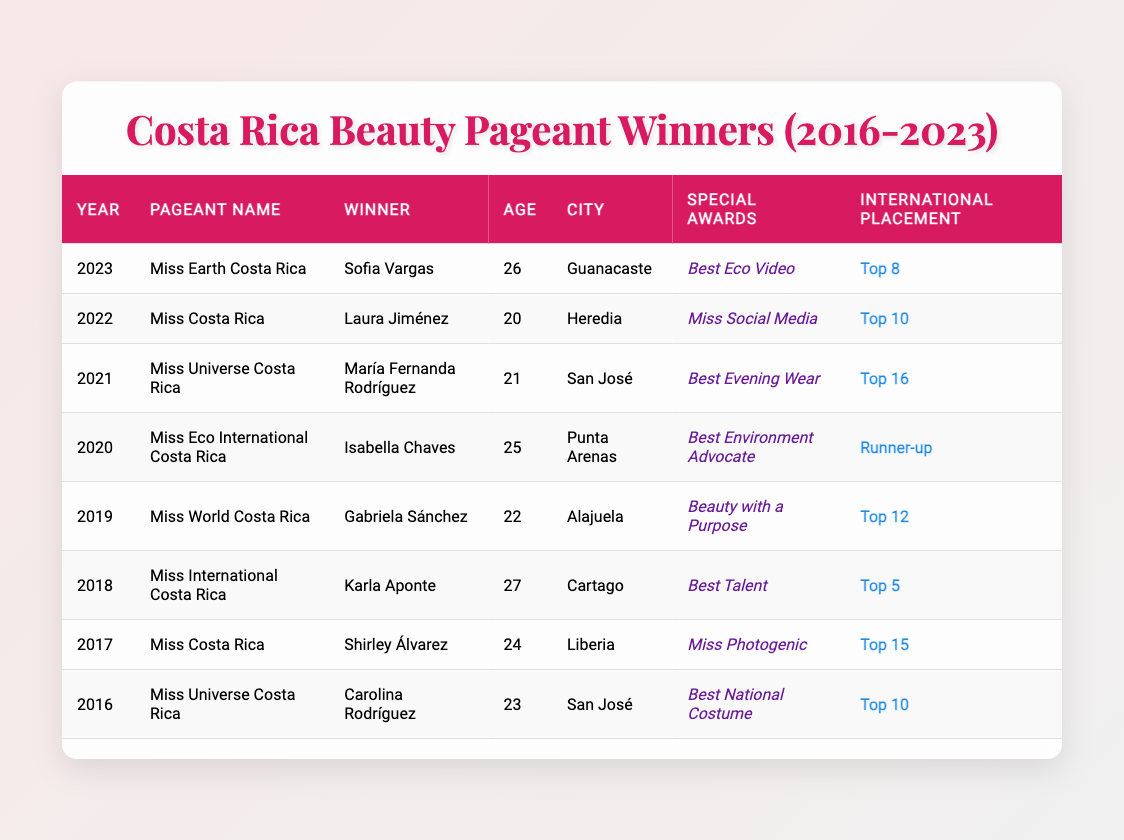What is the name of the winner of Miss Eco International Costa Rica in 2020? The table lists the winners by year, and for the year 2020, under the pageant name "Miss Eco International Costa Rica," the winner's name is Isabella Chaves.
Answer: Isabella Chaves Which winner was the youngest and how old were they when they won? The data shows the ages of all winners. The youngest winner is Laura Jiménez, who won in 2022 at the age of 20.
Answer: Laura Jiménez, 20 What is the average age of the winners from 2016 to 2023? To find the average age, sum the ages of all winners: (23 + 24 + 27 + 22 + 25 + 21 + 20 + 26) =  168. There are 8 winners, so the average age is 168/8 = 21.
Answer: 21 Did any winner receive a special award for "Best National Costume"? According to the table, Carolina Rodríguez won "Best National Costume" in 2016 under the Miss Universe Costa Rica pageant, indicating that this fact is true.
Answer: Yes In how many pageants did the winners place in the top 10 at the international level? Analyzing the placements, Sofia Vargas, Laura Jiménez, and Carolina Rodríguez all placed in the top 10, totaling three winners.
Answer: 3 Which city had the most winners among the various pageants from 2016 to 2023? The table shows the cities of each winner. San José has two winners (Carolina Rodríguez in 2016 and María Fernanda Rodríguez in 2021), while other cities like Liberia and Heredia only have one each, making San José the city with the most winners.
Answer: San José What special award did Karla Aponte win in 2018? The entry for Miss International Costa Rica in 2018 indicates that Karla Aponte won the special award "Best Talent."
Answer: Best Talent Which winner had the highest international placement? Reviewing the international placements, Isabella Chaves had the highest placement in the data with "Runner-up" as her standing in 2020.
Answer: Isabella Chaves Who won the Miss World Costa Rica title in 2019 and what was her age at that time? Referring to the entry for Miss World Costa Rica in 2019, Gabriela Sánchez won the title and was 22 years old at the time.
Answer: Gabriela Sánchez, 22 